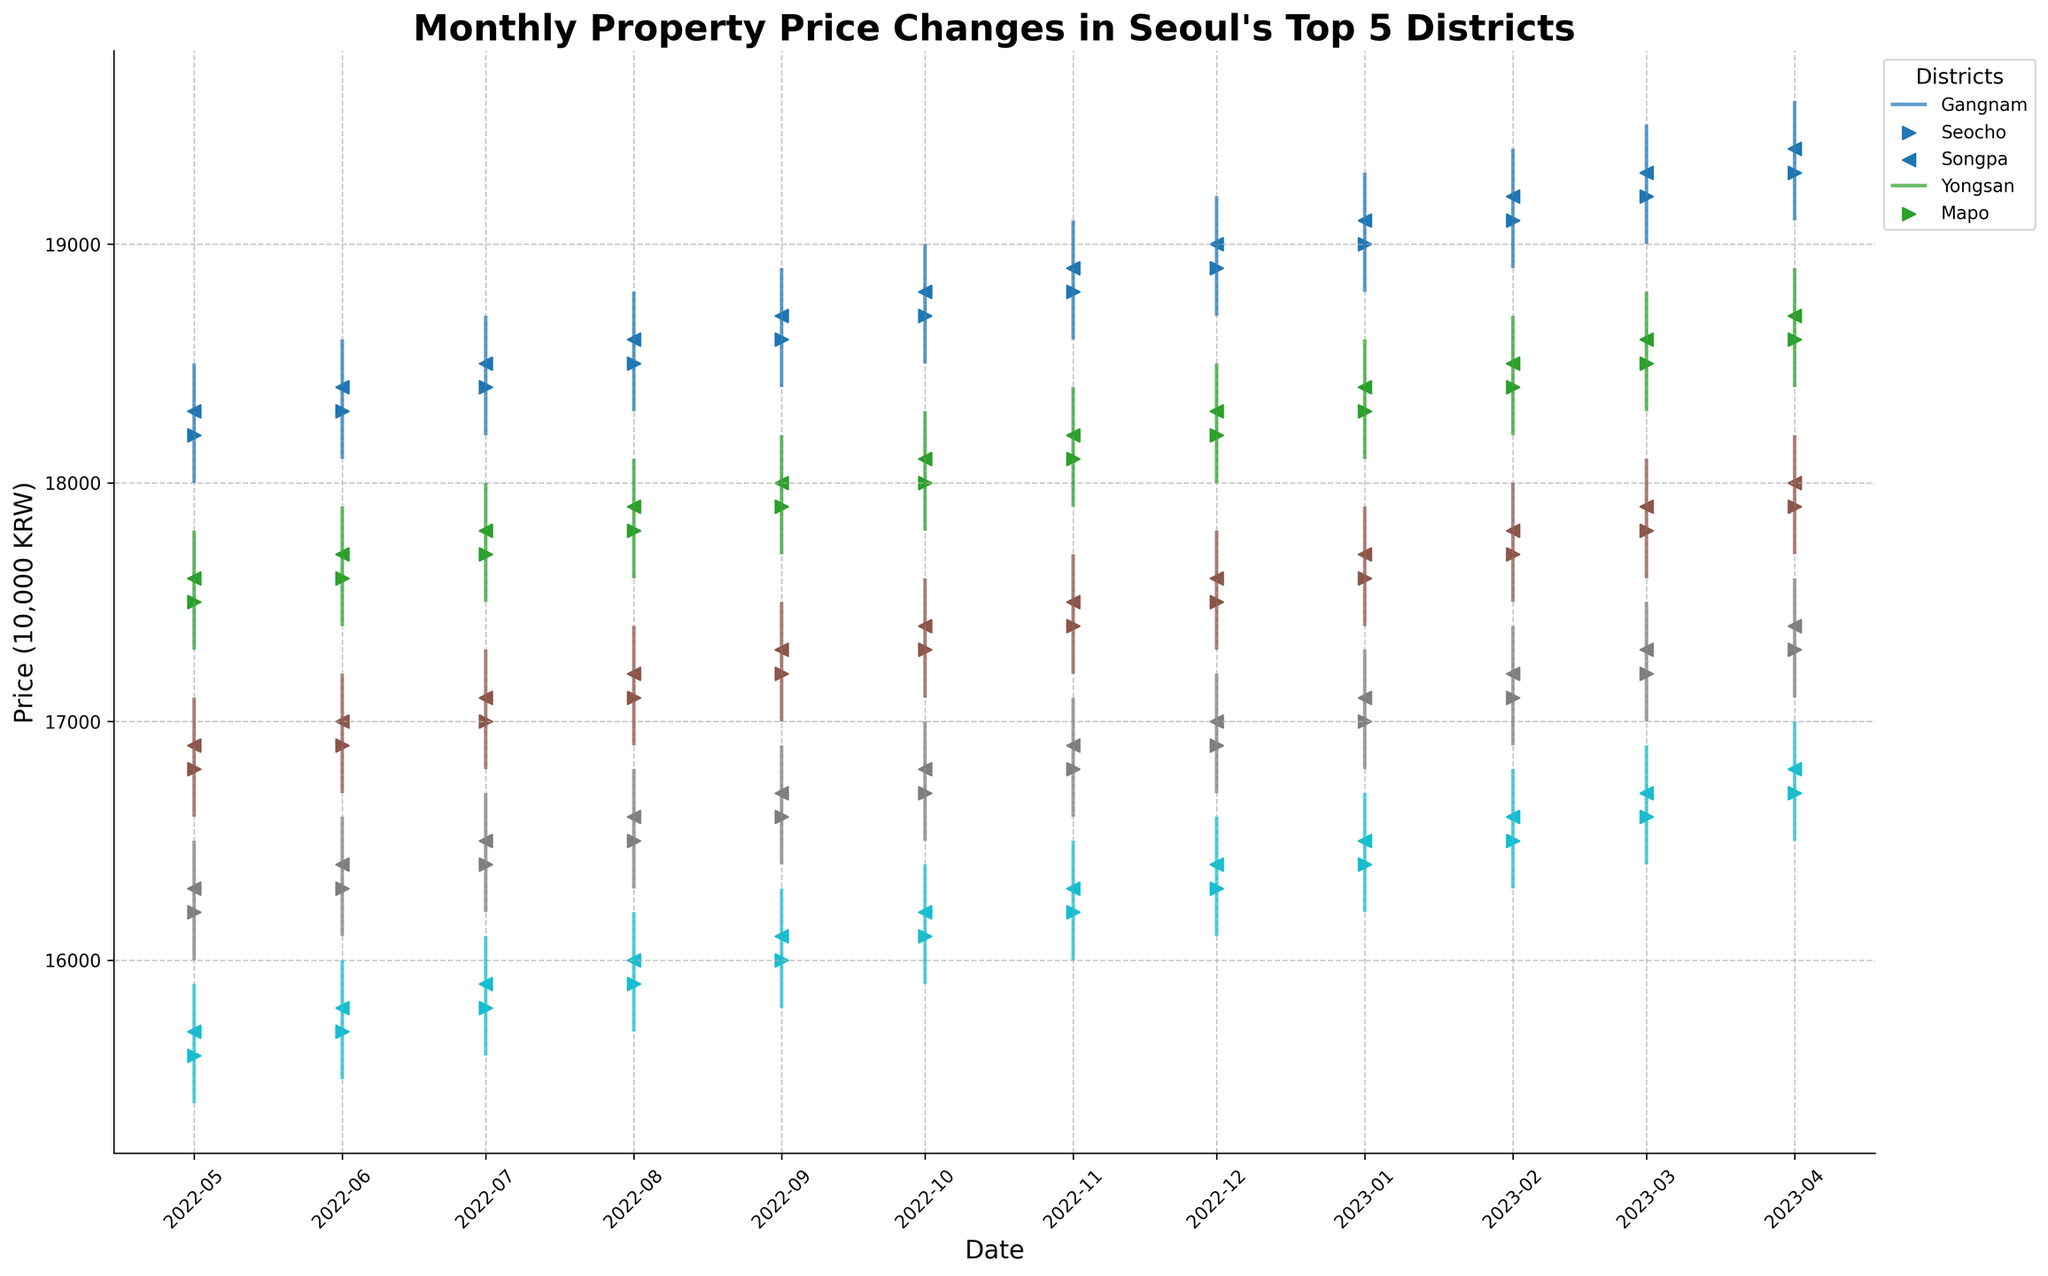What is the title of the plot? The title is located at the top of the figure and summarizes the main purpose of the plot. In this case, it tells us that the figure is about the monthly property price changes in Seoul's top 5 districts.
Answer: Monthly Property Price Changes in Seoul's Top 5 Districts Between Gangnam and Seocho, which district has the highest closing price in April 2023? Check the closing prices in April 2023 for both districts. Gangnam has a closing price of 19,400 10,000 KRW and Seocho has 18,700 10,000 KRW. Compare these values.
Answer: Gangnam Which month shows the highest price for Mapo? Observe the high prices for each month for Mapo. The highest value can be found in April 2023 when the high price reaches 17,000 10,000 KRW.
Answer: April 2023 What is the average closing price for Yongsan over the past year? Sum up all the closing prices for the past 12 months for Yongsan and divide by 12. The monthly closing prices from May 2022 to April 2023 are: 16300, 16400, 16500, 16600, 16700, 16800, 16900, 17000, 17100, 17200, 17300, and 17400. Compute the sum and average.
Answer: 16,900 10,000 KRW In which month did Songpa have the lowest opening price and what was it? Look at Songpa's opening prices for each month. The lowest opening price is in May 2022, which is 16,800 10,000 KRW.
Answer: May 2022, 16,800 10,000 KRW During which months did Gangnam have a closing price above 19,000 10,000 KRW? Identify the months where Gangnam's closing price exceeded 19,000 10,000 KRW. This occurred in December 2022, January 2023, February 2023, March 2023, and April 2023.
Answer: December 2022, January 2023, February 2023, March 2023, April 2023 Compare the price range (difference between high and low) of Seocho in June 2022 and June 2023. Which month had a narrower range? Calculate the price range for each month: June 2022 (17900 - 17400 = 500) and June 2023 (18700 - 18200 = 500). Both months have the same price range of 500.
Answer: Both months had the same range Which month in the past year shows that Mapo had a higher high price compared to Songpa? For each month, compare the high prices of Mapo to Songpa. Specifically, in April 2023, Mapo had a high of 17,000 10,000 KRW, while Songpa had a high of 18,200 10,000 KRW.
Answer: None 